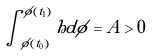Convert formula to latex. <formula><loc_0><loc_0><loc_500><loc_500>\int _ { \phi ( t _ { 0 } ) } ^ { \phi ( t _ { 1 } ) } h d \phi = A > 0</formula> 